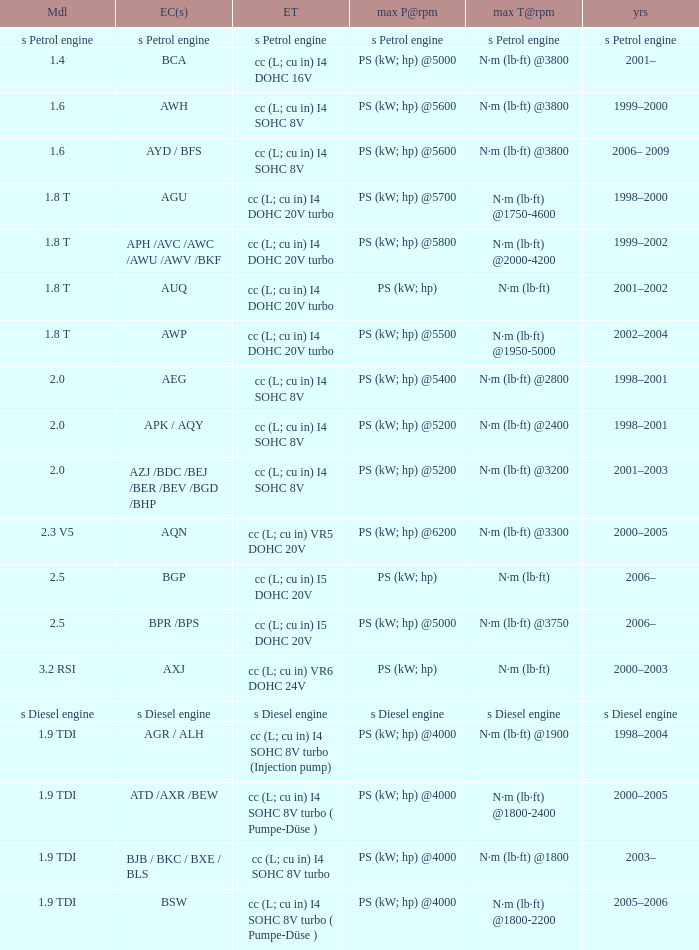Which engine type was used in the model 2.3 v5? Cc (l; cu in) vr5 dohc 20v. 